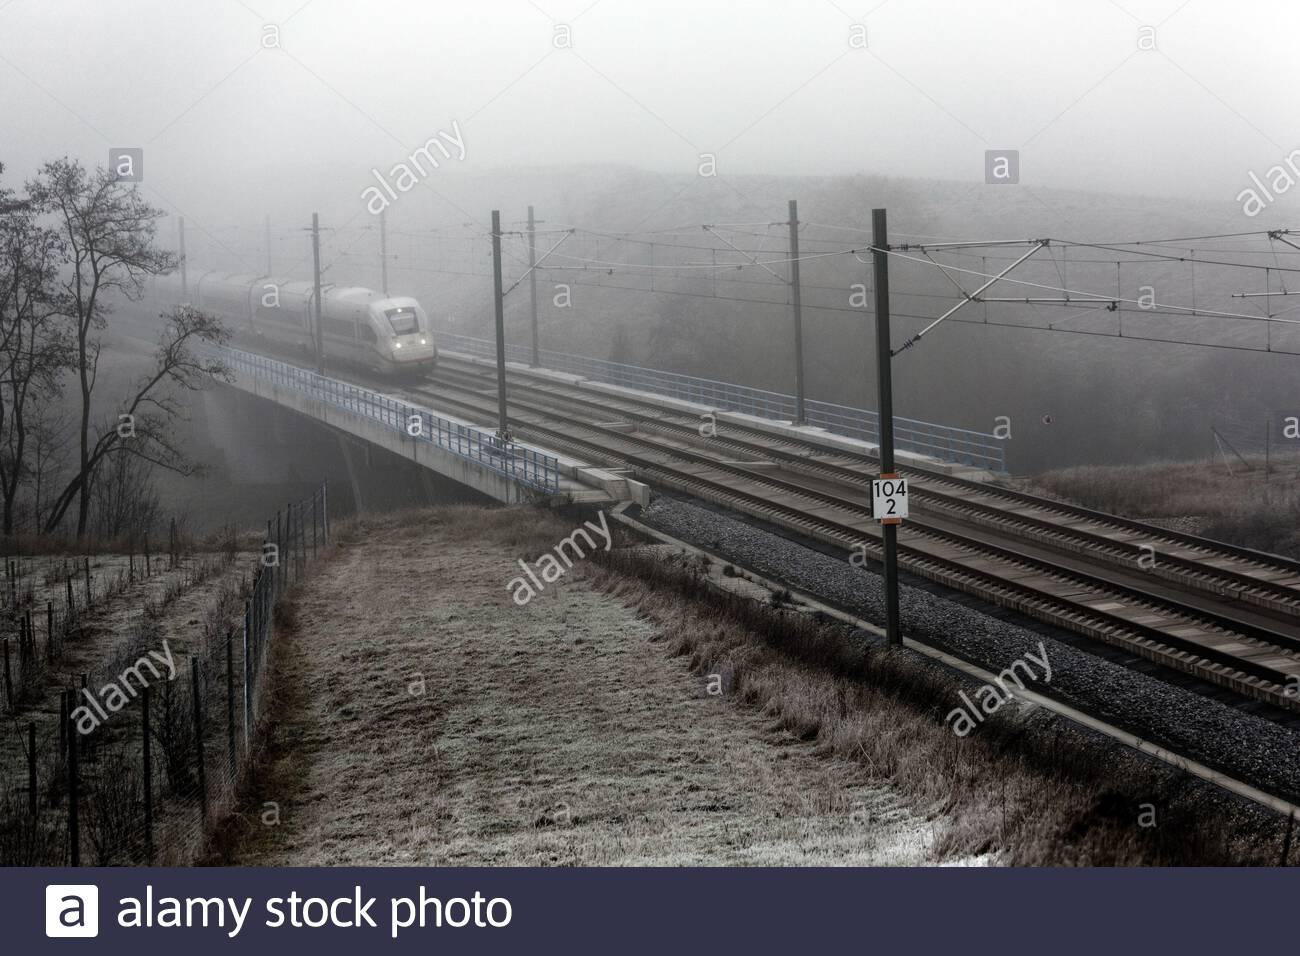How many unicorns are there in the image? 0 